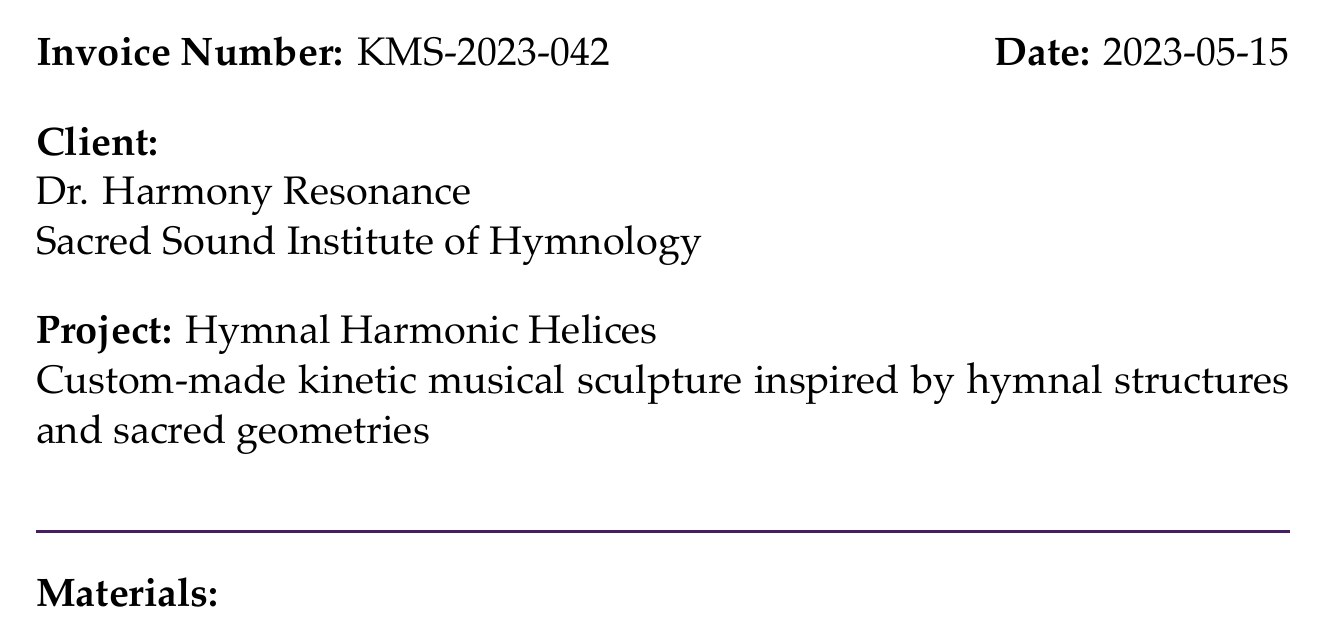What is the invoice number? The invoice number is found at the top of the document and identifies this specific invoice.
Answer: KMS-2023-042 Who is the client? The client's name and institution are provided in the document, making it easy to identify.
Answer: Dr. Harmony Resonance What is the total amount due? The total amount due is calculated including subtotal and tax, and is presented at the end of the document.
Answer: $18,929.16 What is the tax rate applied? The tax rate is specified in the document and indicates the percentage applied to the subtotal.
Answer: 8% How many pieces of custom-tuned chimes are included? The quantity of custom-tuned chimes is presented when detailing the musical elements section of the materials breakdown.
Answer: 24 pieces What is the total cost for the design and planning labor? The total cost for this labor type is derived from the hours worked and the rate per hour, as shown in the labor section.
Answer: $3,000.00 What is the subtotal before tax? The subtotal includes all costs for materials and labor before tax is applied, as presented in the document.
Answer: $17,527.00 What item has the highest price per unit? The highest price per unit item is listed under the materials section, which provides specific costs for each item.
Answer: Brass rods What payment terms are specified in the document? The payment terms indicate how the client should proceed with payments, which is a standard inclusion in invoices.
Answer: 50% due upon approval, remaining 50% due upon completion 